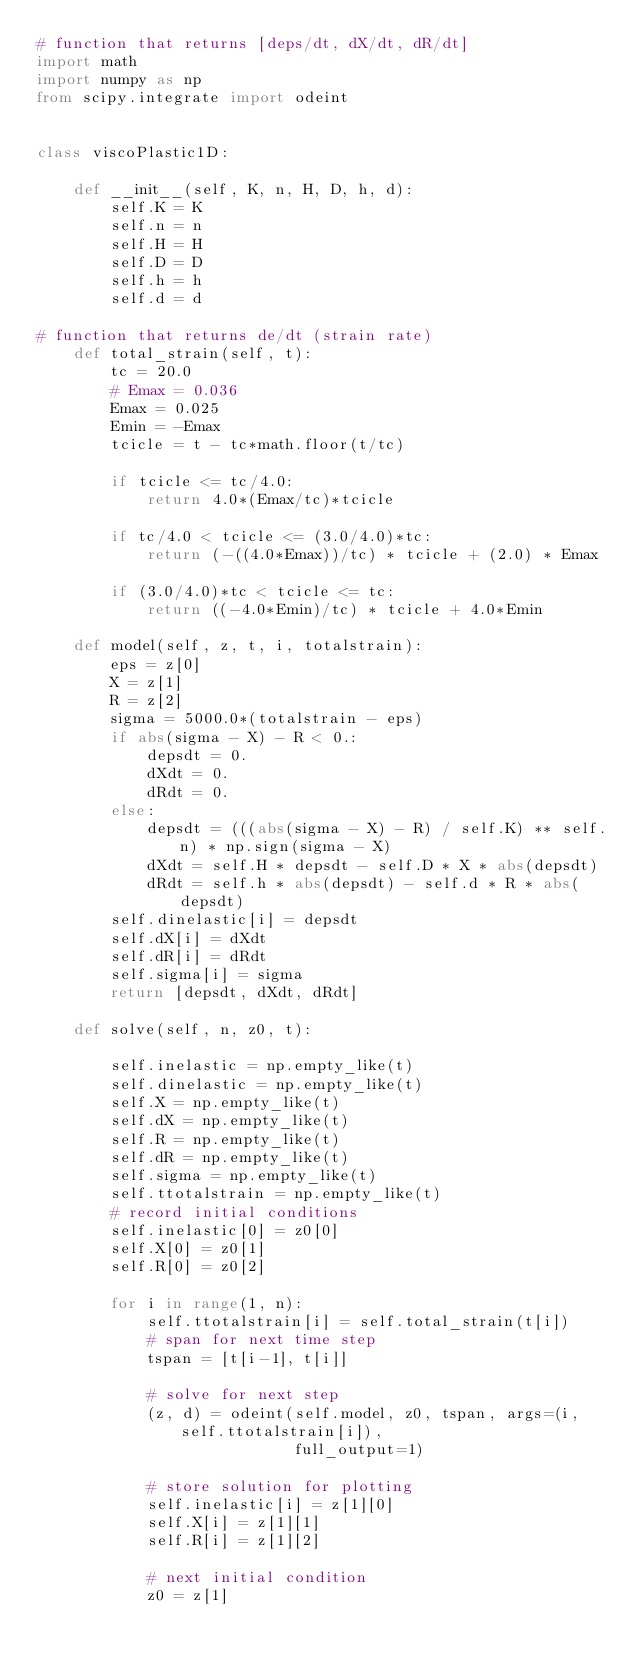Convert code to text. <code><loc_0><loc_0><loc_500><loc_500><_Python_># function that returns [deps/dt, dX/dt, dR/dt]
import math
import numpy as np
from scipy.integrate import odeint


class viscoPlastic1D:

    def __init__(self, K, n, H, D, h, d):
        self.K = K
        self.n = n
        self.H = H
        self.D = D
        self.h = h
        self.d = d

# function that returns de/dt (strain rate)
    def total_strain(self, t):
        tc = 20.0
        # Emax = 0.036
        Emax = 0.025
        Emin = -Emax
        tcicle = t - tc*math.floor(t/tc)

        if tcicle <= tc/4.0:
            return 4.0*(Emax/tc)*tcicle

        if tc/4.0 < tcicle <= (3.0/4.0)*tc:
            return (-((4.0*Emax))/tc) * tcicle + (2.0) * Emax

        if (3.0/4.0)*tc < tcicle <= tc:
            return ((-4.0*Emin)/tc) * tcicle + 4.0*Emin

    def model(self, z, t, i, totalstrain):
        eps = z[0]
        X = z[1]
        R = z[2]
        sigma = 5000.0*(totalstrain - eps)
        if abs(sigma - X) - R < 0.:
            depsdt = 0.
            dXdt = 0.
            dRdt = 0.
        else:
            depsdt = (((abs(sigma - X) - R) / self.K) ** self.n) * np.sign(sigma - X)
            dXdt = self.H * depsdt - self.D * X * abs(depsdt)
            dRdt = self.h * abs(depsdt) - self.d * R * abs(depsdt)
        self.dinelastic[i] = depsdt
        self.dX[i] = dXdt
        self.dR[i] = dRdt
        self.sigma[i] = sigma
        return [depsdt, dXdt, dRdt]

    def solve(self, n, z0, t):

        self.inelastic = np.empty_like(t)
        self.dinelastic = np.empty_like(t)
        self.X = np.empty_like(t)
        self.dX = np.empty_like(t)
        self.R = np.empty_like(t)
        self.dR = np.empty_like(t)
        self.sigma = np.empty_like(t)
        self.ttotalstrain = np.empty_like(t)
        # record initial conditions
        self.inelastic[0] = z0[0]
        self.X[0] = z0[1]
        self.R[0] = z0[2]

        for i in range(1, n):
            self.ttotalstrain[i] = self.total_strain(t[i])
            # span for next time step
            tspan = [t[i-1], t[i]]

            # solve for next step
            (z, d) = odeint(self.model, z0, tspan, args=(i, self.ttotalstrain[i]),
                            full_output=1)

            # store solution for plotting
            self.inelastic[i] = z[1][0]
            self.X[i] = z[1][1]
            self.R[i] = z[1][2]

            # next initial condition
            z0 = z[1]
</code> 